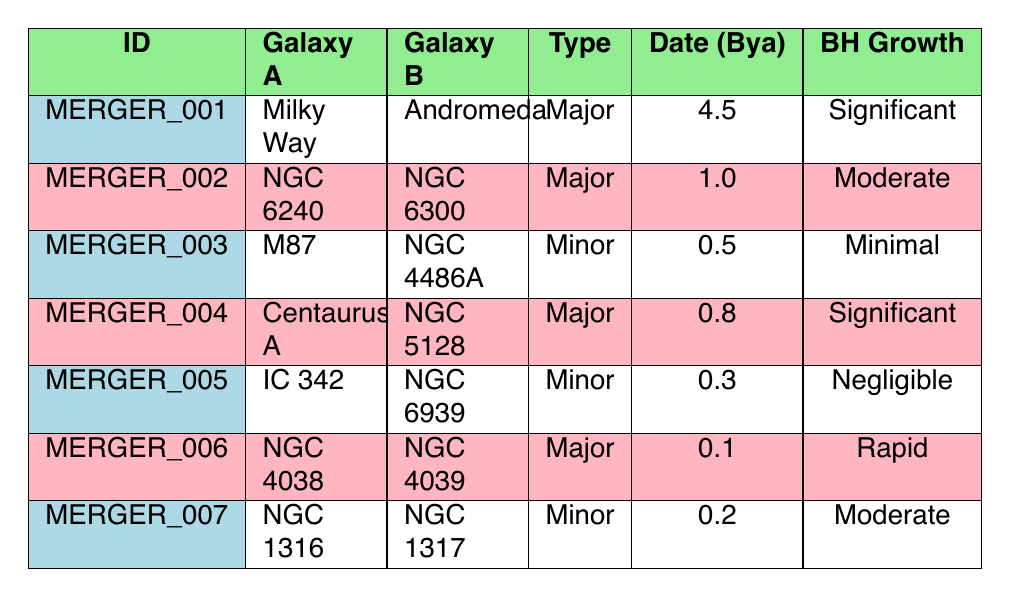What are the names of the galaxies involved in the merger event identified as MERGER_001? According to the table, the merger event with ID MERGER_001 involves the Milky Way and Andromeda, as stated in the Galaxy A and Galaxy B columns respectively.
Answer: Milky Way and Andromeda How many major merger events are listed in the table? By examining the Type column, we can identify the merger events classified as Major. The events MERGER_001, MERGER_002, MERGER_004, and MERGER_006 are major events, resulting in a total of 4 major merger events.
Answer: 4 Is there any merger event that resulted in negligible black hole growth? The table indicates that MERGER_005 resulted in negligible black hole growth, as stated in the BH Growth column. Thus, the answer to the question is yes.
Answer: Yes What is the total count of merger events that occurred within the last 1 billion years? The list of merger events occurring in the last 1 billion years are MERGER_002, MERGER_003, MERGER_004, MERGER_005, MERGER_006, and MERGER_007, totaling 5 events when counting these rows.
Answer: 5 For major mergers, what is the average black hole growth rating based upon the provided types? Considering that the significant ratings are "Significant", "Moderate", and "Rapid", we assign numerical values to these ratings: Significant (2), Moderate (1), and Rapid (3). For the major mergers (MERGER_001, MERGER_002, MERGER_004, MERGER_006), we calculate their average as (2 + 1 + 2 + 3) / 4 = 2, suggesting an average growth rating of 2 (significant).
Answer: 2 